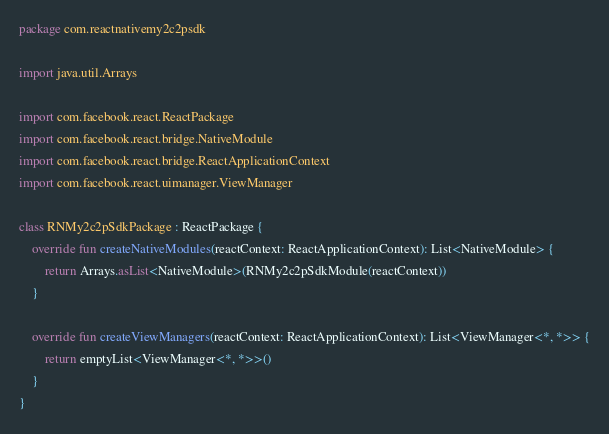<code> <loc_0><loc_0><loc_500><loc_500><_Kotlin_>package com.reactnativemy2c2psdk

import java.util.Arrays

import com.facebook.react.ReactPackage
import com.facebook.react.bridge.NativeModule
import com.facebook.react.bridge.ReactApplicationContext
import com.facebook.react.uimanager.ViewManager

class RNMy2c2pSdkPackage : ReactPackage {
    override fun createNativeModules(reactContext: ReactApplicationContext): List<NativeModule> {
        return Arrays.asList<NativeModule>(RNMy2c2pSdkModule(reactContext))
    }

    override fun createViewManagers(reactContext: ReactApplicationContext): List<ViewManager<*, *>> {
        return emptyList<ViewManager<*, *>>()
    }
}
</code> 